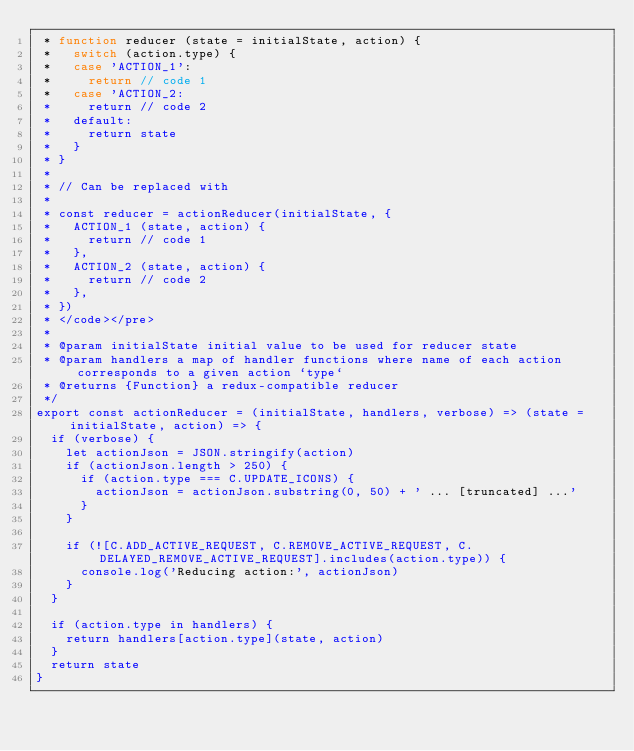Convert code to text. <code><loc_0><loc_0><loc_500><loc_500><_JavaScript_> * function reducer (state = initialState, action) {
 *   switch (action.type) {
 *   case 'ACTION_1':
 *     return // code 1
 *   case 'ACTION_2:
 *     return // code 2
 *   default:
 *     return state
 *   }
 * }
 *
 * // Can be replaced with
 *
 * const reducer = actionReducer(initialState, {
 *   ACTION_1 (state, action) {
 *     return // code 1
 *   },
 *   ACTION_2 (state, action) {
 *     return // code 2
 *   },
 * })
 * </code></pre>
 *
 * @param initialState initial value to be used for reducer state
 * @param handlers a map of handler functions where name of each action corresponds to a given action `type`
 * @returns {Function} a redux-compatible reducer
 */
export const actionReducer = (initialState, handlers, verbose) => (state = initialState, action) => {
  if (verbose) {
    let actionJson = JSON.stringify(action)
    if (actionJson.length > 250) {
      if (action.type === C.UPDATE_ICONS) {
        actionJson = actionJson.substring(0, 50) + ' ... [truncated] ...'
      }
    }

    if (![C.ADD_ACTIVE_REQUEST, C.REMOVE_ACTIVE_REQUEST, C.DELAYED_REMOVE_ACTIVE_REQUEST].includes(action.type)) {
      console.log('Reducing action:', actionJson)
    }
  }

  if (action.type in handlers) {
    return handlers[action.type](state, action)
  }
  return state
}
</code> 